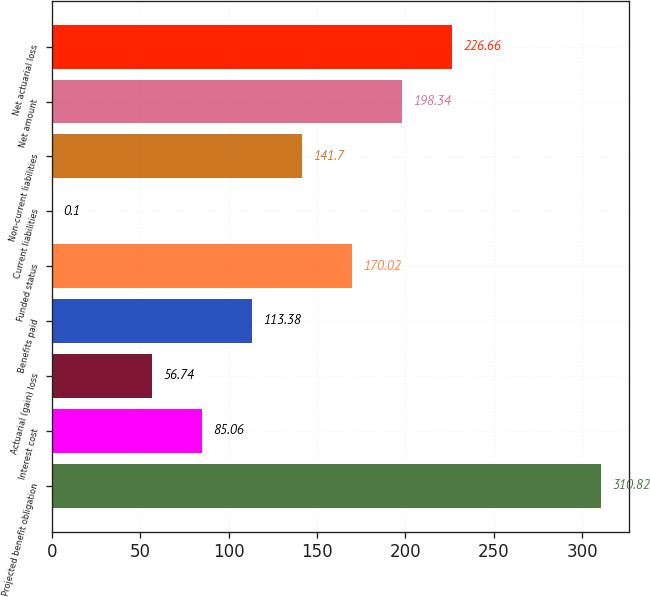Convert chart. <chart><loc_0><loc_0><loc_500><loc_500><bar_chart><fcel>Projected benefit obligation<fcel>Interest cost<fcel>Actuarial (gain) loss<fcel>Benefits paid<fcel>Funded status<fcel>Current liabilities<fcel>Non-current liabilities<fcel>Net amount<fcel>Net actuarial loss<nl><fcel>310.82<fcel>85.06<fcel>56.74<fcel>113.38<fcel>170.02<fcel>0.1<fcel>141.7<fcel>198.34<fcel>226.66<nl></chart> 